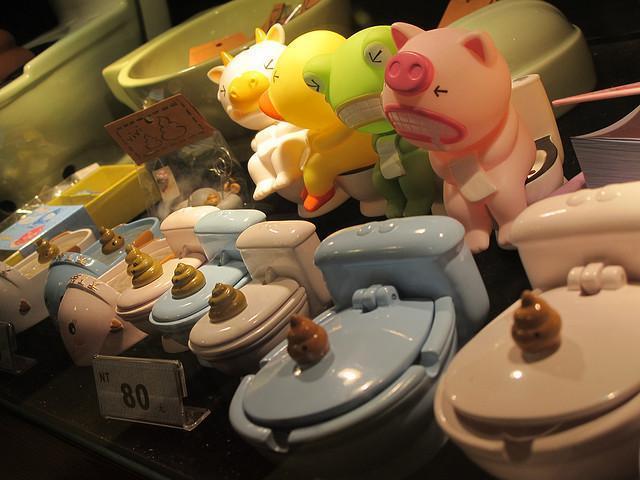How many toilets can be seen?
Give a very brief answer. 7. How many skis is the boy holding?
Give a very brief answer. 0. 